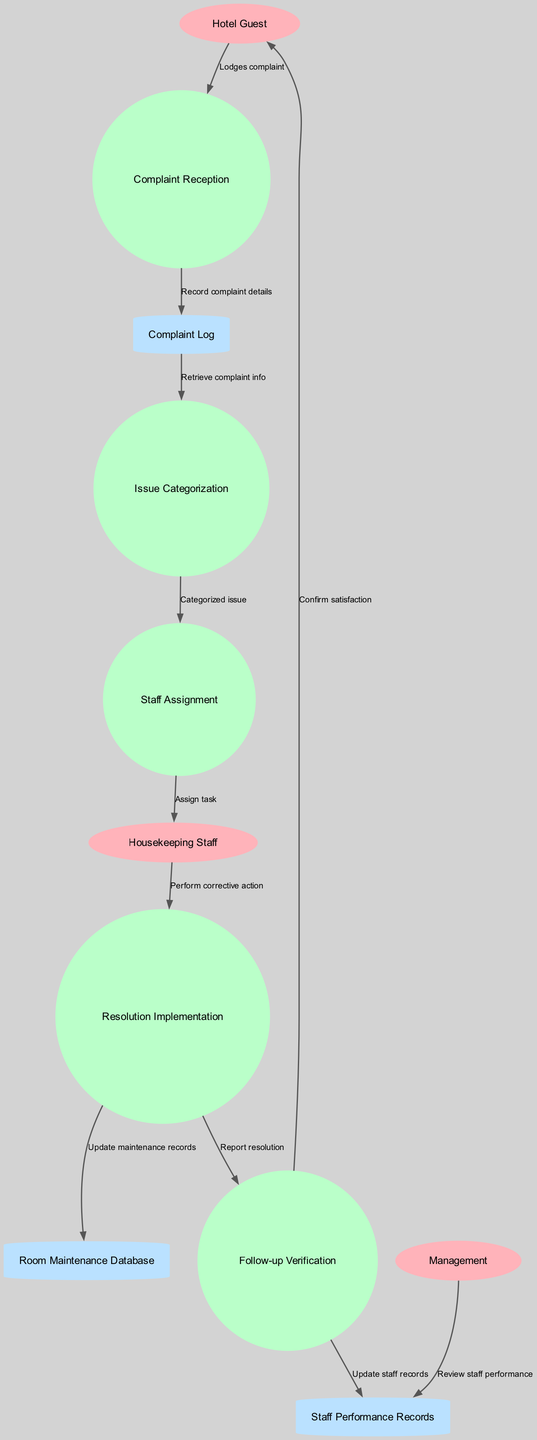How many external entities are present in the diagram? The diagram lists three external entities: Hotel Guest, Housekeeping Staff, and Management. Counting these gives a total of three external entities.
Answer: 3 What process follows 'Issue Categorization' in the flow? The arrow labeled 'Categorized issue' leads from 'Issue Categorization' to 'Staff Assignment', indicating that 'Staff Assignment' is the next process in the flow after 'Issue Categorization'.
Answer: Staff Assignment What is the last step where a guest is involved in the process? In the flow, the final interaction with the Hotel Guest occurs at the 'Follow-up Verification' process, which confirms their satisfaction after the complaint has been addressed.
Answer: Follow-up Verification How many processes are there in total? The diagram includes five processes: Complaint Reception, Issue Categorization, Staff Assignment, Resolution Implementation, and Follow-up Verification. Adding these gives a total of five processes.
Answer: 5 Which data store is used to record complaints? The flow from 'Complaint Reception' to 'Complaint Log' shows that the data store for recording complaints is the 'Complaint Log'.
Answer: Complaint Log What does the process 'Follow-up Verification' do with the staff records? The flow indicates that after 'Follow-up Verification', there is an update to 'Staff Performance Records', which implies that 'Follow-up Verification' updates these records based on the resolution process.
Answer: Update staff records Which external entity receives confirmation of satisfaction? According to the diagram, the 'Follow-up Verification' process sends confirmation of satisfaction back to the 'Hotel Guest', indicating that they are informed about the resolution.
Answer: Hotel Guest What action is taken after corrective actions are performed? The diagram shows that following the corrective action performed by Housekeeping Staff, there is a reporting step leading to 'Follow-up Verification'. This indicates that the resolution is reported for satisfaction confirmation.
Answer: Report resolution What relationship exists between 'Staff Assignment' and 'Housekeeping Staff'? The labeled flow 'Assign task' indicates a direct relationship where 'Staff Assignment' communicates tasks to 'Housekeeping Staff', specifying the function of task assignment.
Answer: Assign task 